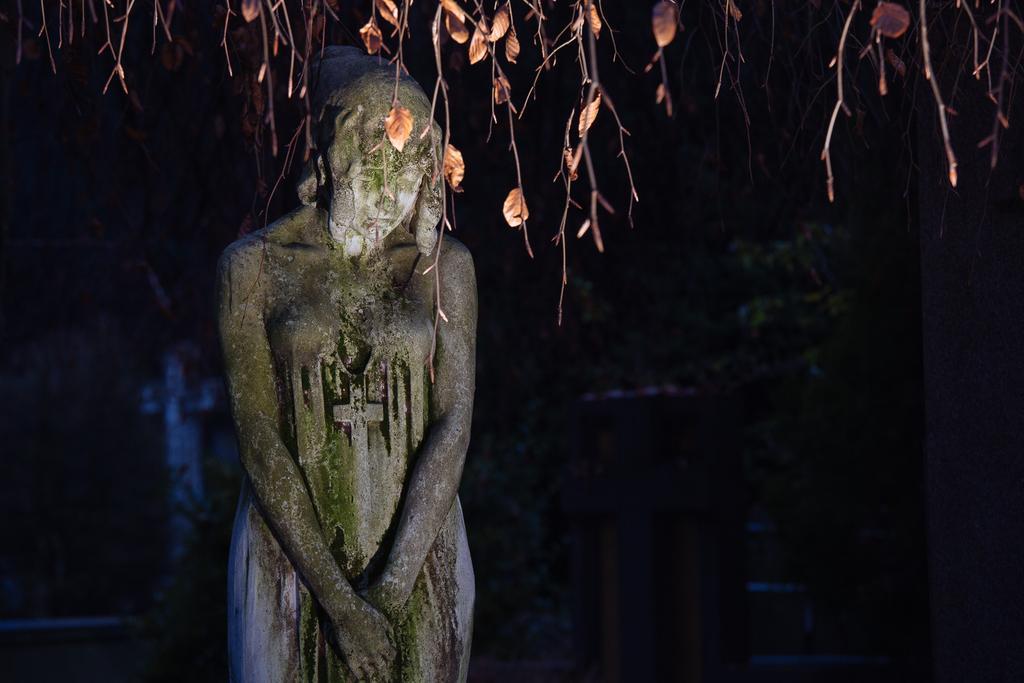Can you describe this image briefly? In this image, this looks like a sculpture of the woman standing. I think these are the branches with leaves, which are hanging. The background looks blurry. 